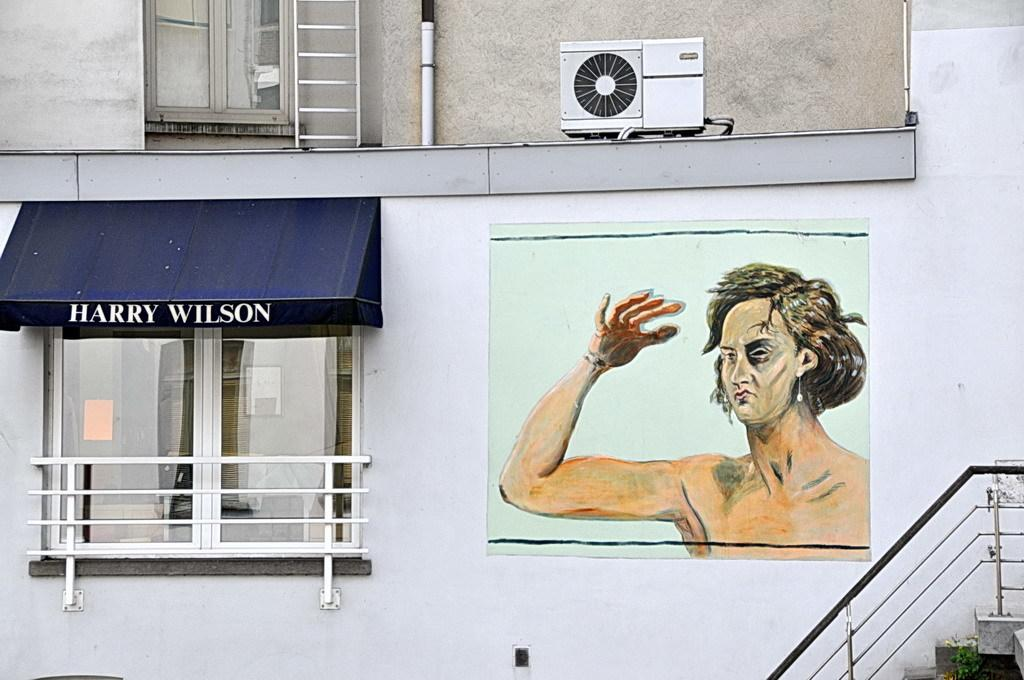<image>
Create a compact narrative representing the image presented. The blue awning on the building says Harry Wilson 